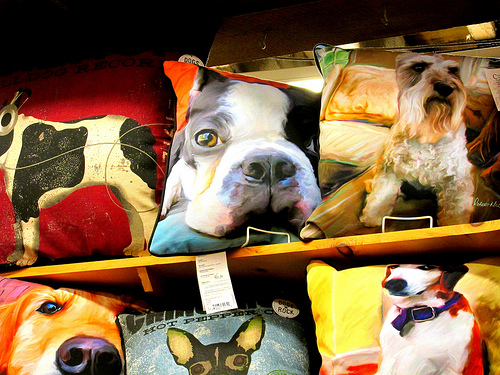<image>
Is the pillow to the right of the pillow? Yes. From this viewpoint, the pillow is positioned to the right side relative to the pillow. Is the shelf next to the pillow? No. The shelf is not positioned next to the pillow. They are located in different areas of the scene. 